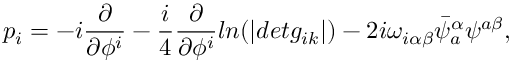<formula> <loc_0><loc_0><loc_500><loc_500>p _ { i } = - i \frac { \partial } { \partial \phi ^ { i } } - \frac { i } { 4 } \frac { \partial } { \partial \phi ^ { i } } \ln ( | d e t g _ { i k } | ) - 2 i \omega _ { i \alpha \beta } \bar { \psi } _ { a } ^ { \alpha } \psi ^ { a \beta } ,</formula> 